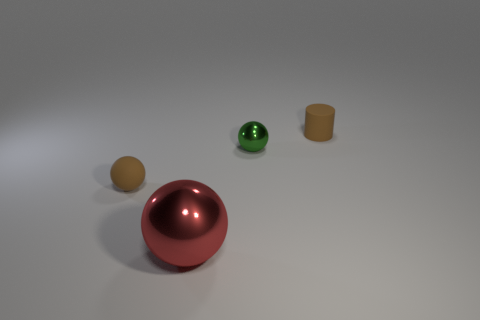The other large ball that is made of the same material as the green sphere is what color?
Provide a short and direct response. Red. What shape is the matte object that is the same color as the matte sphere?
Your answer should be compact. Cylinder. Are there an equal number of small green shiny things in front of the large shiny ball and brown matte spheres that are to the right of the brown ball?
Make the answer very short. Yes. The brown matte thing in front of the sphere that is on the right side of the red object is what shape?
Your answer should be very brief. Sphere. There is a brown object that is the same shape as the green thing; what is it made of?
Provide a succinct answer. Rubber. There is a rubber cylinder that is the same size as the green metallic object; what color is it?
Offer a very short reply. Brown. Is the number of large things behind the tiny rubber sphere the same as the number of big red shiny balls?
Offer a terse response. No. What is the color of the small thing right of the green sphere that is on the left side of the matte cylinder?
Ensure brevity in your answer.  Brown. There is a brown object that is behind the small brown thing on the left side of the small rubber cylinder; how big is it?
Your answer should be very brief. Small. There is a object that is the same color as the rubber cylinder; what size is it?
Ensure brevity in your answer.  Small. 